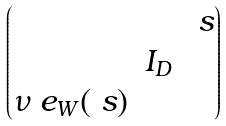Convert formula to latex. <formula><loc_0><loc_0><loc_500><loc_500>\begin{pmatrix} & & \ s \\ & I _ { D } & \\ \nu \ e _ { W } ( \ s ) & & \end{pmatrix}</formula> 